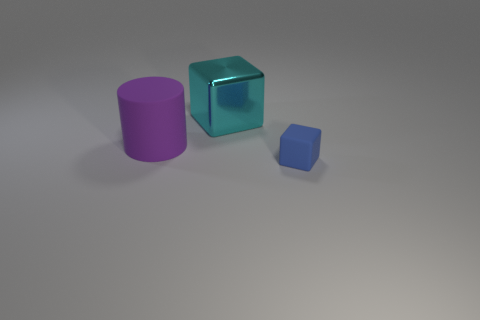Add 1 cyan shiny objects. How many objects exist? 4 Subtract all cylinders. How many objects are left? 2 Add 1 blue things. How many blue things are left? 2 Add 1 tiny red cylinders. How many tiny red cylinders exist? 1 Subtract 0 yellow balls. How many objects are left? 3 Subtract all purple rubber things. Subtract all tiny green rubber blocks. How many objects are left? 2 